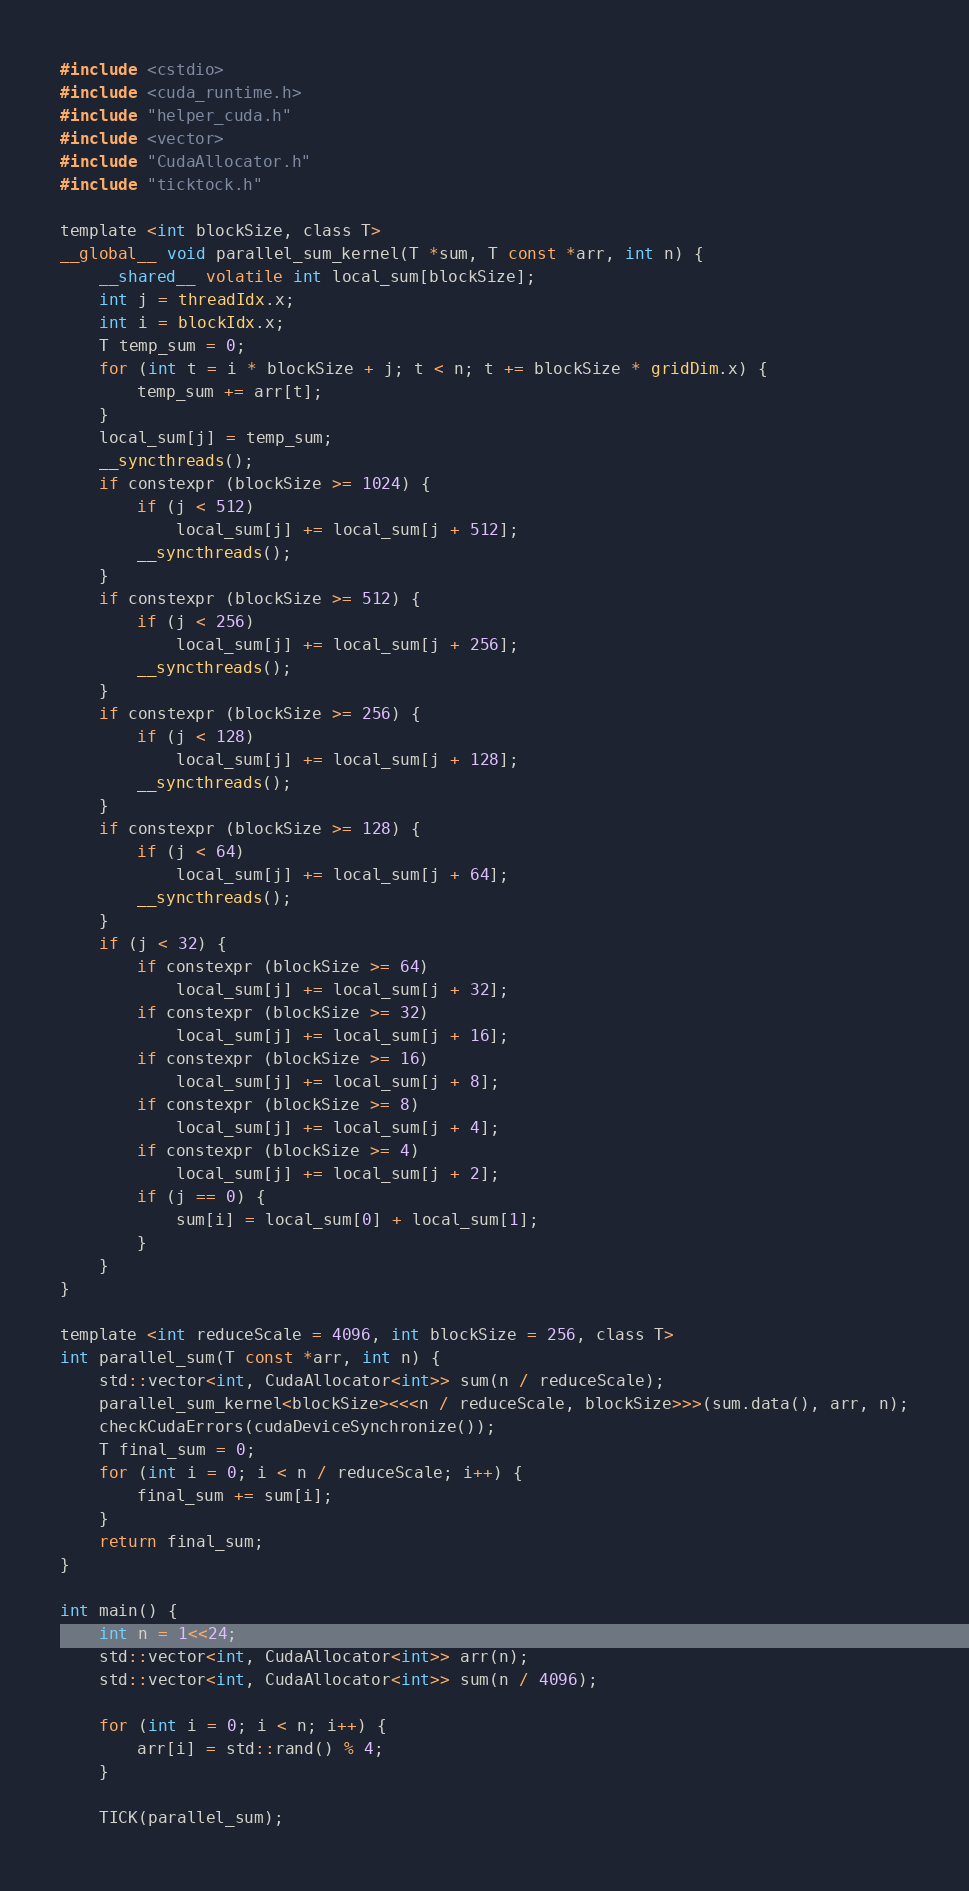<code> <loc_0><loc_0><loc_500><loc_500><_Cuda_>#include <cstdio>
#include <cuda_runtime.h>
#include "helper_cuda.h"
#include <vector>
#include "CudaAllocator.h"
#include "ticktock.h"

template <int blockSize, class T>
__global__ void parallel_sum_kernel(T *sum, T const *arr, int n) {
    __shared__ volatile int local_sum[blockSize];
    int j = threadIdx.x;
    int i = blockIdx.x;
    T temp_sum = 0;
    for (int t = i * blockSize + j; t < n; t += blockSize * gridDim.x) {
        temp_sum += arr[t];
    }
    local_sum[j] = temp_sum;
    __syncthreads();
    if constexpr (blockSize >= 1024) {
        if (j < 512)
            local_sum[j] += local_sum[j + 512];
        __syncthreads();
    }
    if constexpr (blockSize >= 512) {
        if (j < 256)
            local_sum[j] += local_sum[j + 256];
        __syncthreads();
    }
    if constexpr (blockSize >= 256) {
        if (j < 128)
            local_sum[j] += local_sum[j + 128];
        __syncthreads();
    }
    if constexpr (blockSize >= 128) {
        if (j < 64)
            local_sum[j] += local_sum[j + 64];
        __syncthreads();
    }
    if (j < 32) {
        if constexpr (blockSize >= 64)
            local_sum[j] += local_sum[j + 32];
        if constexpr (blockSize >= 32)
            local_sum[j] += local_sum[j + 16];
        if constexpr (blockSize >= 16)
            local_sum[j] += local_sum[j + 8];
        if constexpr (blockSize >= 8)
            local_sum[j] += local_sum[j + 4];
        if constexpr (blockSize >= 4)
            local_sum[j] += local_sum[j + 2];
        if (j == 0) {
            sum[i] = local_sum[0] + local_sum[1];
        }
    }
}

template <int reduceScale = 4096, int blockSize = 256, class T>
int parallel_sum(T const *arr, int n) {
    std::vector<int, CudaAllocator<int>> sum(n / reduceScale);
    parallel_sum_kernel<blockSize><<<n / reduceScale, blockSize>>>(sum.data(), arr, n);
    checkCudaErrors(cudaDeviceSynchronize());
    T final_sum = 0;
    for (int i = 0; i < n / reduceScale; i++) {
        final_sum += sum[i];
    }
    return final_sum;
}

int main() {
    int n = 1<<24;
    std::vector<int, CudaAllocator<int>> arr(n);
    std::vector<int, CudaAllocator<int>> sum(n / 4096);

    for (int i = 0; i < n; i++) {
        arr[i] = std::rand() % 4;
    }

    TICK(parallel_sum);</code> 